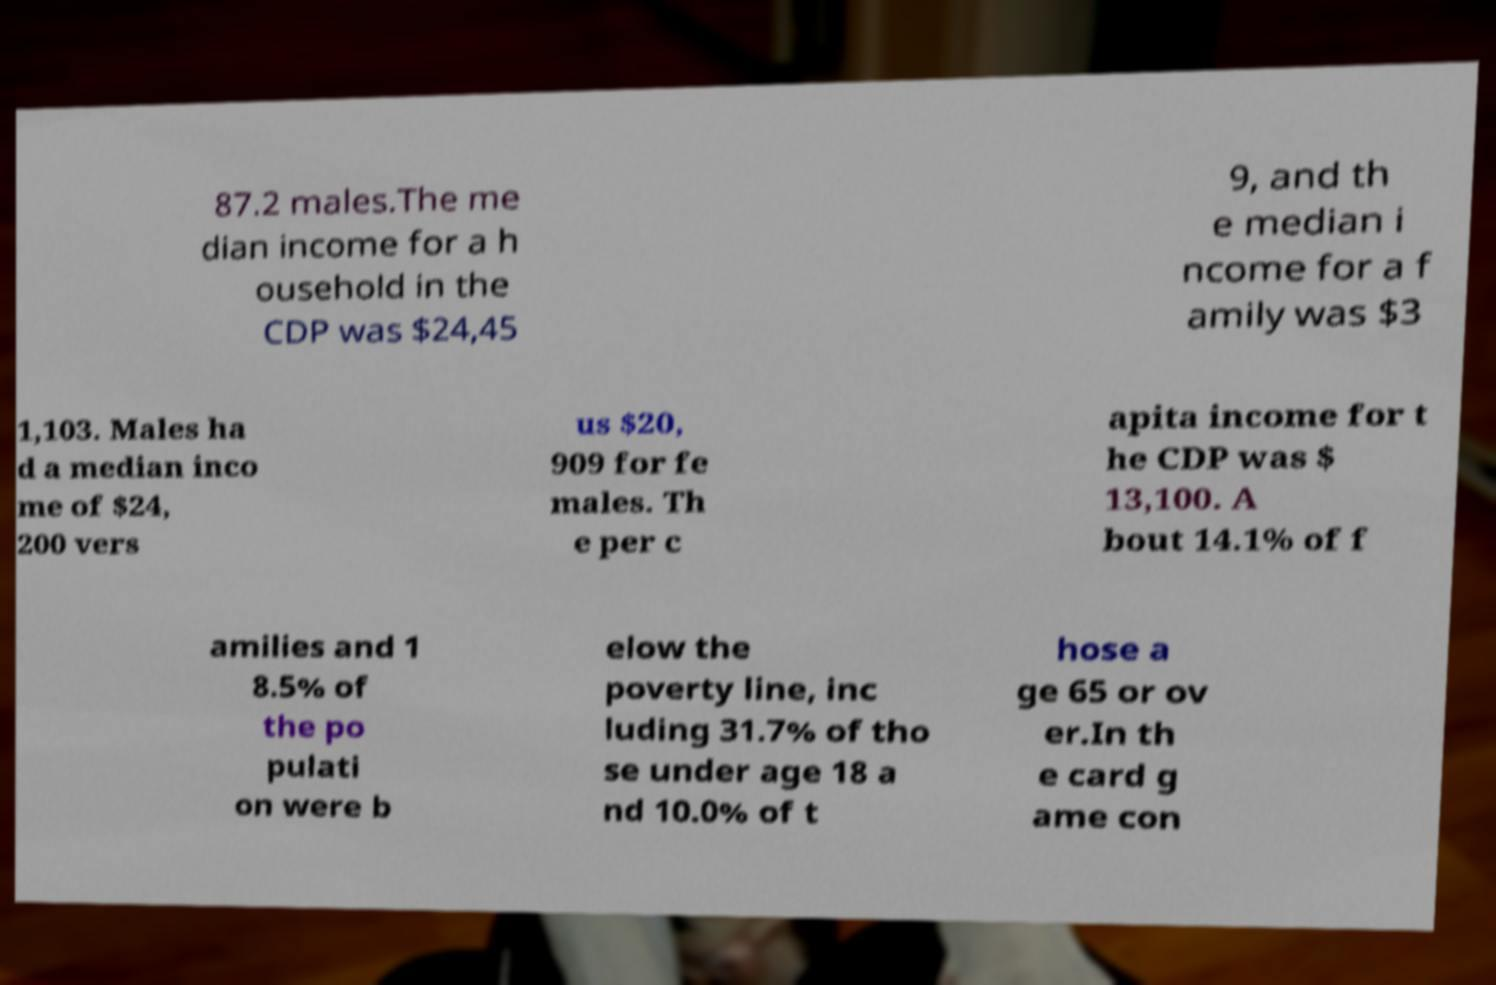Can you read and provide the text displayed in the image?This photo seems to have some interesting text. Can you extract and type it out for me? 87.2 males.The me dian income for a h ousehold in the CDP was $24,45 9, and th e median i ncome for a f amily was $3 1,103. Males ha d a median inco me of $24, 200 vers us $20, 909 for fe males. Th e per c apita income for t he CDP was $ 13,100. A bout 14.1% of f amilies and 1 8.5% of the po pulati on were b elow the poverty line, inc luding 31.7% of tho se under age 18 a nd 10.0% of t hose a ge 65 or ov er.In th e card g ame con 